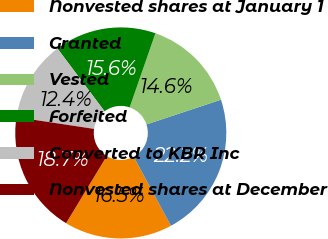Convert chart to OTSL. <chart><loc_0><loc_0><loc_500><loc_500><pie_chart><fcel>Nonvested shares at January 1<fcel>Granted<fcel>Vested<fcel>Forfeited<fcel>Converted to KBR Inc<fcel>Nonvested shares at December<nl><fcel>16.55%<fcel>22.22%<fcel>14.58%<fcel>15.57%<fcel>12.37%<fcel>18.72%<nl></chart> 